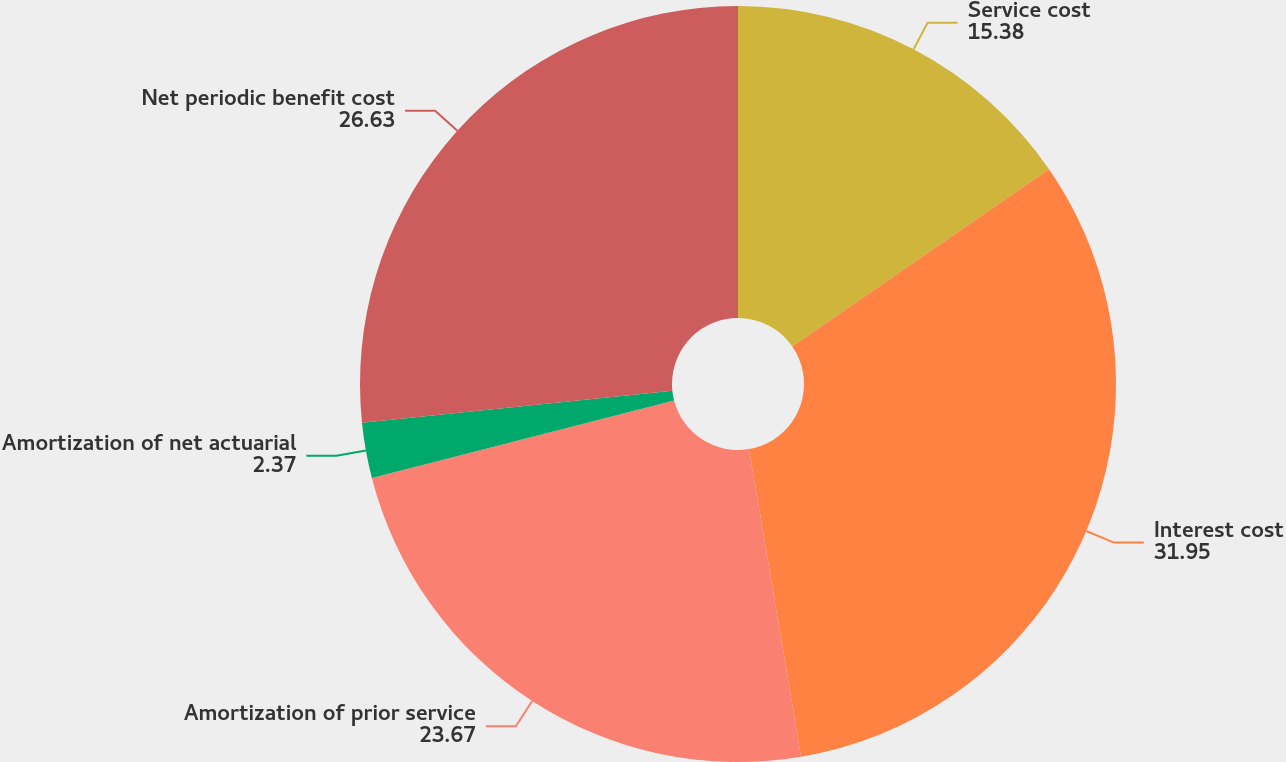Convert chart. <chart><loc_0><loc_0><loc_500><loc_500><pie_chart><fcel>Service cost<fcel>Interest cost<fcel>Amortization of prior service<fcel>Amortization of net actuarial<fcel>Net periodic benefit cost<nl><fcel>15.38%<fcel>31.95%<fcel>23.67%<fcel>2.37%<fcel>26.63%<nl></chart> 